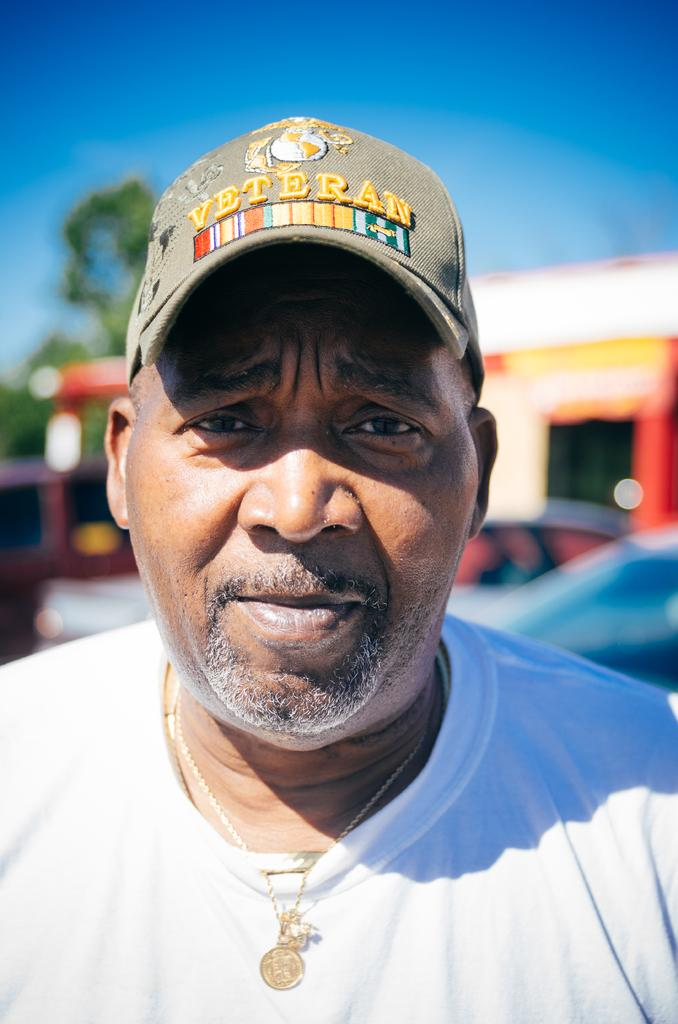What is the main subject of the image? There is a person in the image. What is the person wearing on their head? The person is wearing a cap. Can you describe the background of the image? The background of the image is blurry. What color is the silverware on the bed in the image? There is no silverware or bed present in the image; it features a person wearing a cap with a blurry background. 